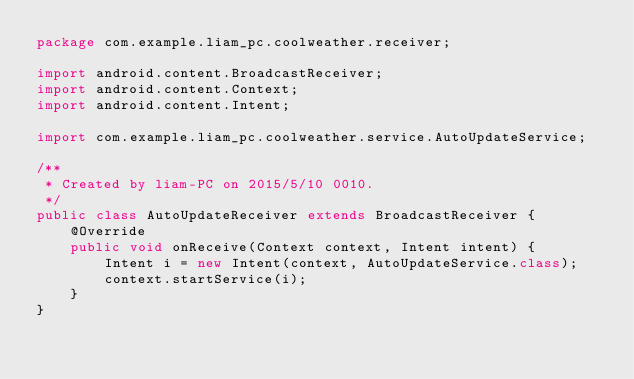<code> <loc_0><loc_0><loc_500><loc_500><_Java_>package com.example.liam_pc.coolweather.receiver;

import android.content.BroadcastReceiver;
import android.content.Context;
import android.content.Intent;

import com.example.liam_pc.coolweather.service.AutoUpdateService;

/**
 * Created by liam-PC on 2015/5/10 0010.
 */
public class AutoUpdateReceiver extends BroadcastReceiver {
    @Override
    public void onReceive(Context context, Intent intent) {
        Intent i = new Intent(context, AutoUpdateService.class);
        context.startService(i);
    }
}
</code> 